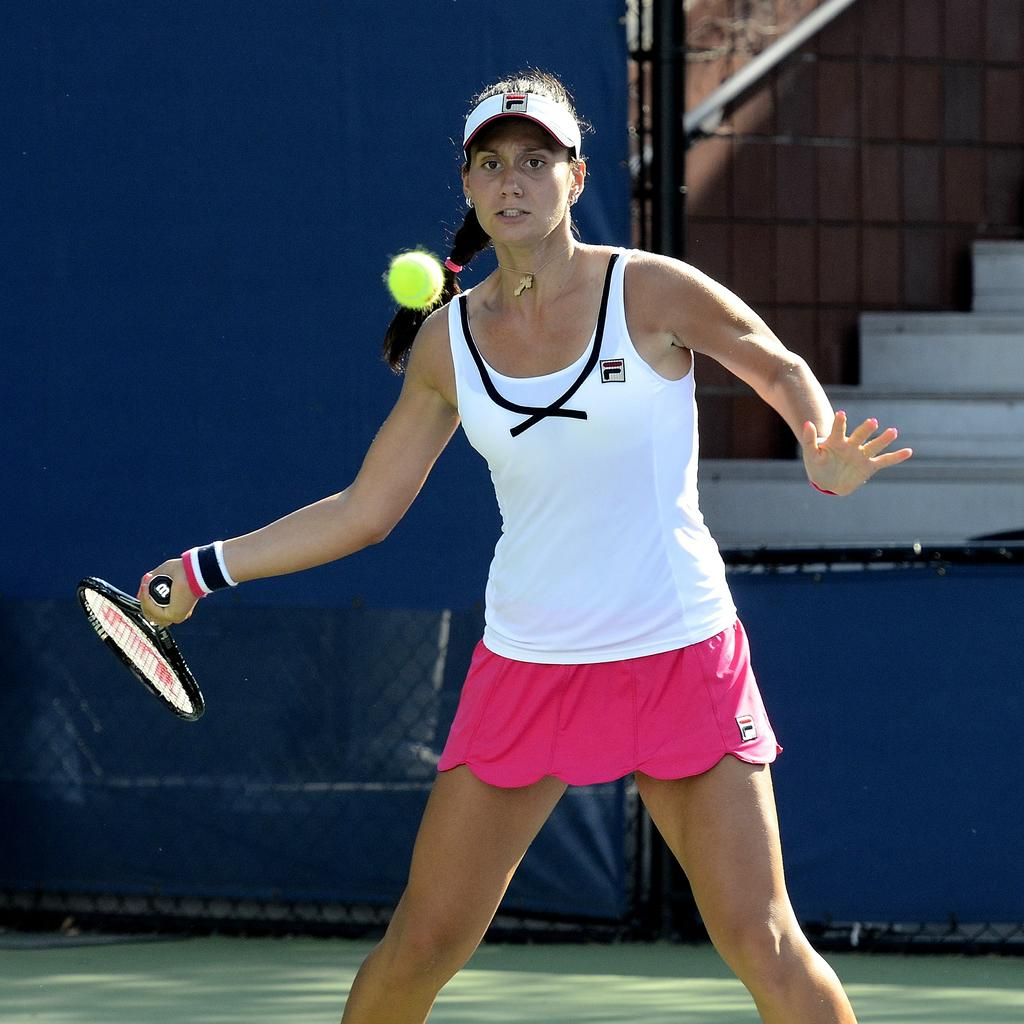Who is present in the image? There is a woman in the image. What is the woman holding in the image? The woman is holding a racket. What object is in front of the woman? There is a ball in front of the woman. What is the woman's posture in the image? The woman is standing. What can be seen in the background of the image? There are stairs in the background of the image. What type of pleasure can be seen on the woman's face in the image? The provided facts do not mention the woman's facial expression or any indication of pleasure. 